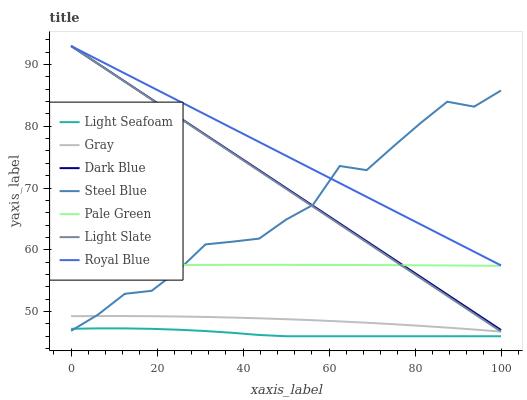Does Light Seafoam have the minimum area under the curve?
Answer yes or no. Yes. Does Royal Blue have the maximum area under the curve?
Answer yes or no. Yes. Does Light Slate have the minimum area under the curve?
Answer yes or no. No. Does Light Slate have the maximum area under the curve?
Answer yes or no. No. Is Royal Blue the smoothest?
Answer yes or no. Yes. Is Steel Blue the roughest?
Answer yes or no. Yes. Is Light Slate the smoothest?
Answer yes or no. No. Is Light Slate the roughest?
Answer yes or no. No. Does Light Seafoam have the lowest value?
Answer yes or no. Yes. Does Light Slate have the lowest value?
Answer yes or no. No. Does Dark Blue have the highest value?
Answer yes or no. Yes. Does Steel Blue have the highest value?
Answer yes or no. No. Is Light Seafoam less than Royal Blue?
Answer yes or no. Yes. Is Royal Blue greater than Light Seafoam?
Answer yes or no. Yes. Does Light Slate intersect Dark Blue?
Answer yes or no. Yes. Is Light Slate less than Dark Blue?
Answer yes or no. No. Is Light Slate greater than Dark Blue?
Answer yes or no. No. Does Light Seafoam intersect Royal Blue?
Answer yes or no. No. 